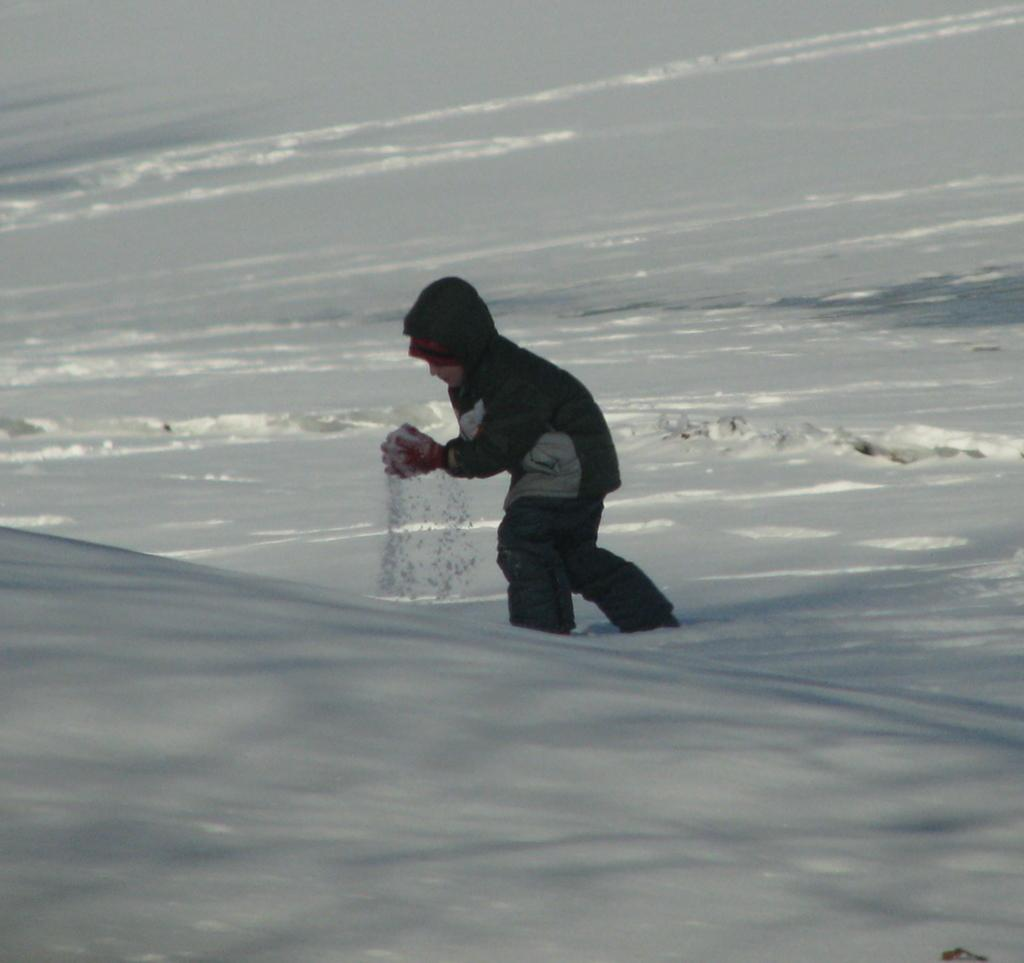What is the main subject of the image? There is a boy standing in the image. What is the condition of the ground in the image? The ground appears to be covered in snow. How many rings are visible on the boy's fingers in the image? There are no rings visible on the boy's fingers in the image. What type of guide is present in the image to help the boy navigate the snow? There is no guide present in the image; the boy is standing alone. 